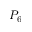<formula> <loc_0><loc_0><loc_500><loc_500>P _ { 6 }</formula> 